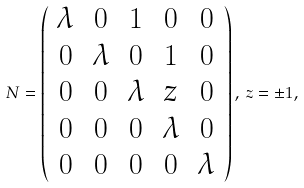<formula> <loc_0><loc_0><loc_500><loc_500>N = \left ( \begin{array} { c c c c c } \lambda & 0 & 1 & 0 & 0 \\ 0 & \lambda & 0 & 1 & 0 \\ 0 & 0 & \lambda & z & 0 \\ 0 & 0 & 0 & \lambda & 0 \\ 0 & 0 & 0 & 0 & \lambda \end{array} \right ) , \, z = \pm 1 ,</formula> 